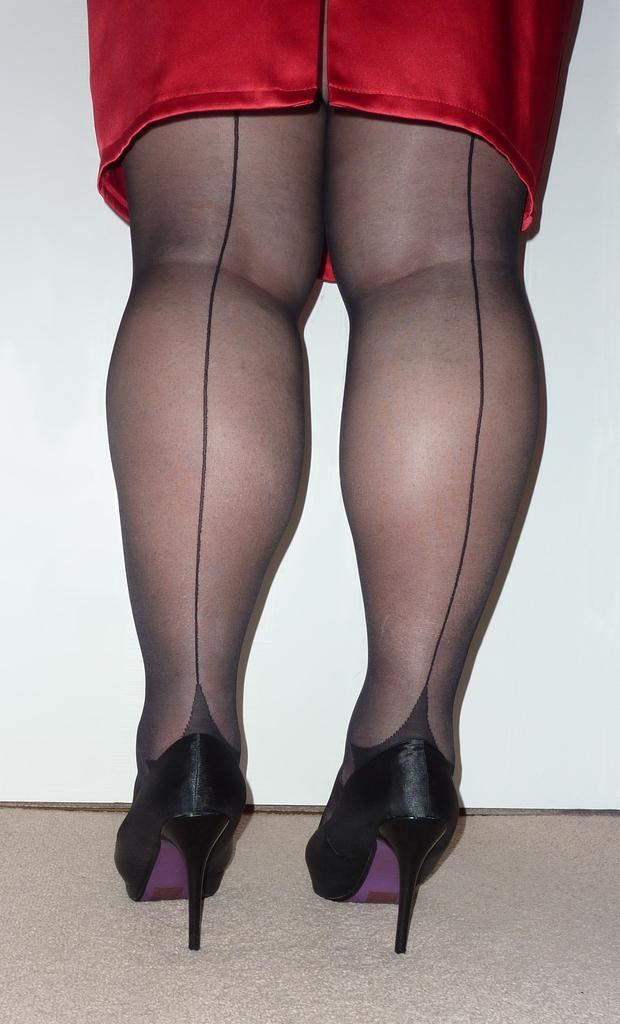What part of a person's body is visible in the center of the image? The legs of a person are visible in the center of the image. What type of toothbrush is being used by the person in the image? There is no toothbrush present in the image; only the person's legs are visible. What color is the thread used to sew the person's clothes in the image? There is no information about the person's clothes or the color of any thread in the image. 